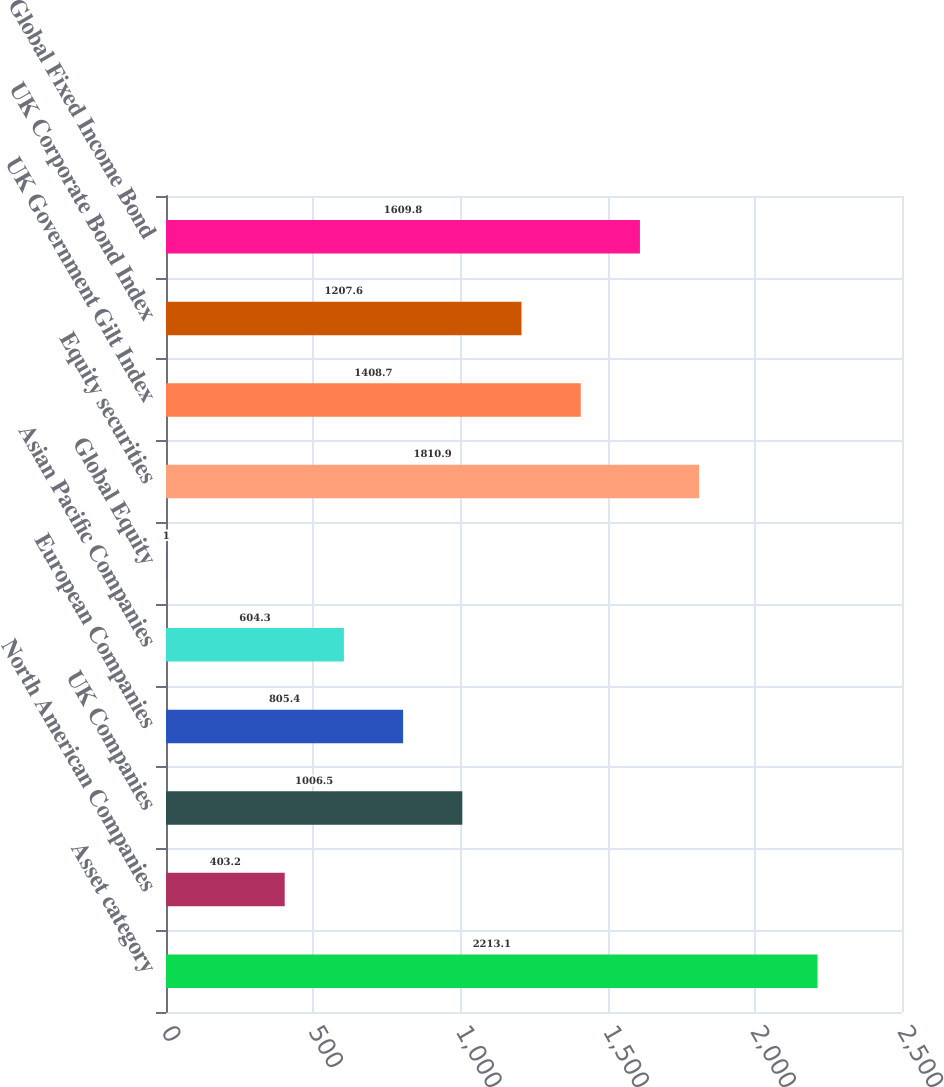Convert chart. <chart><loc_0><loc_0><loc_500><loc_500><bar_chart><fcel>Asset category<fcel>North American Companies<fcel>UK Companies<fcel>European Companies<fcel>Asian Pacific Companies<fcel>Global Equity<fcel>Equity securities<fcel>UK Government Gilt Index<fcel>UK Corporate Bond Index<fcel>Global Fixed Income Bond<nl><fcel>2213.1<fcel>403.2<fcel>1006.5<fcel>805.4<fcel>604.3<fcel>1<fcel>1810.9<fcel>1408.7<fcel>1207.6<fcel>1609.8<nl></chart> 